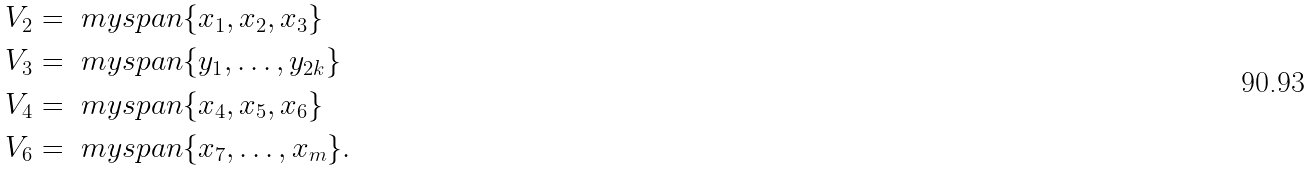<formula> <loc_0><loc_0><loc_500><loc_500>V _ { 2 } & = \ m y s p a n \{ x _ { 1 } , x _ { 2 } , x _ { 3 } \} \\ V _ { 3 } & = \ m y s p a n \{ y _ { 1 } , \dots , y _ { 2 k } \} \\ V _ { 4 } & = \ m y s p a n \{ x _ { 4 } , x _ { 5 } , x _ { 6 } \} \\ V _ { 6 } & = \ m y s p a n \{ x _ { 7 } , \dots , x _ { m } \} .</formula> 